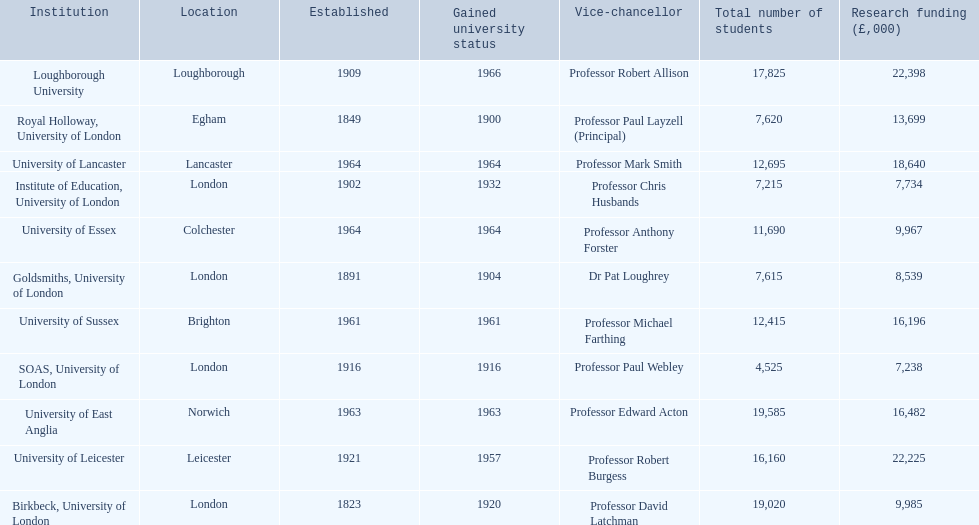What are the institutions in the 1994 group? Birkbeck, University of London, University of East Anglia, University of Essex, Goldsmiths, University of London, Institute of Education, University of London, University of Lancaster, University of Leicester, Loughborough University, Royal Holloway, University of London, SOAS, University of London, University of Sussex. Which of these was made a university most recently? Loughborough University. 